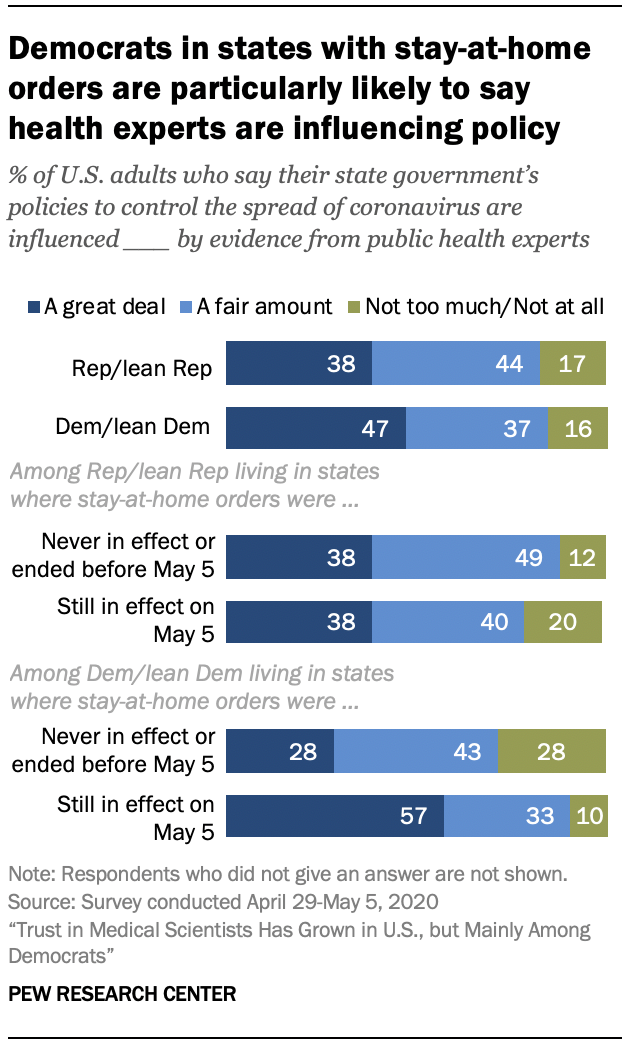Outline some significant characteristics in this image. The lowest value of the navy blue bar is 28. The ratio of the lowest value of the yellow bar to the navy blue bar is 0.218055556... 